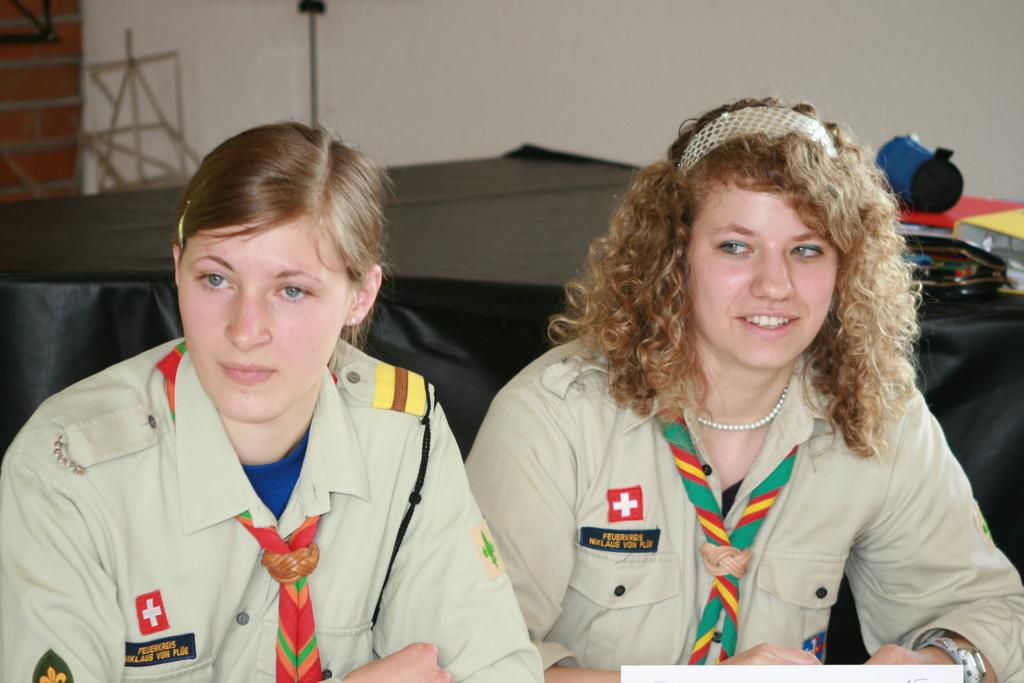How many people are in the image? There are two women in the image. What are the women doing in the image? The women are sitting on chairs. What can be seen in the background of the image? There is a table and a wall in the background of the image. What is on the table in the image? There are items on the table. What type of pest can be seen crawling on the wall in the image? There is no pest visible in the image; only the two women, chairs, table, and wall are present. 